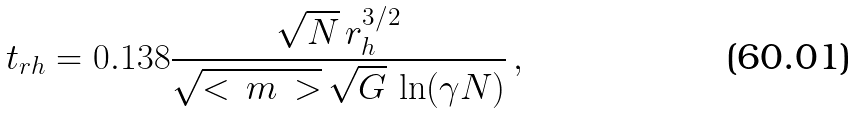<formula> <loc_0><loc_0><loc_500><loc_500>t _ { r h } = 0 . 1 3 8 \frac { \sqrt { N } \, r _ { h } ^ { 3 / 2 } } { \sqrt { < \, m \, > } \, \sqrt { G } \, \ln ( \gamma N ) } \, ,</formula> 